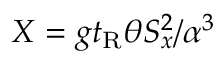<formula> <loc_0><loc_0><loc_500><loc_500>X = g t _ { R } \theta S _ { x } ^ { 2 } / \alpha ^ { 3 }</formula> 